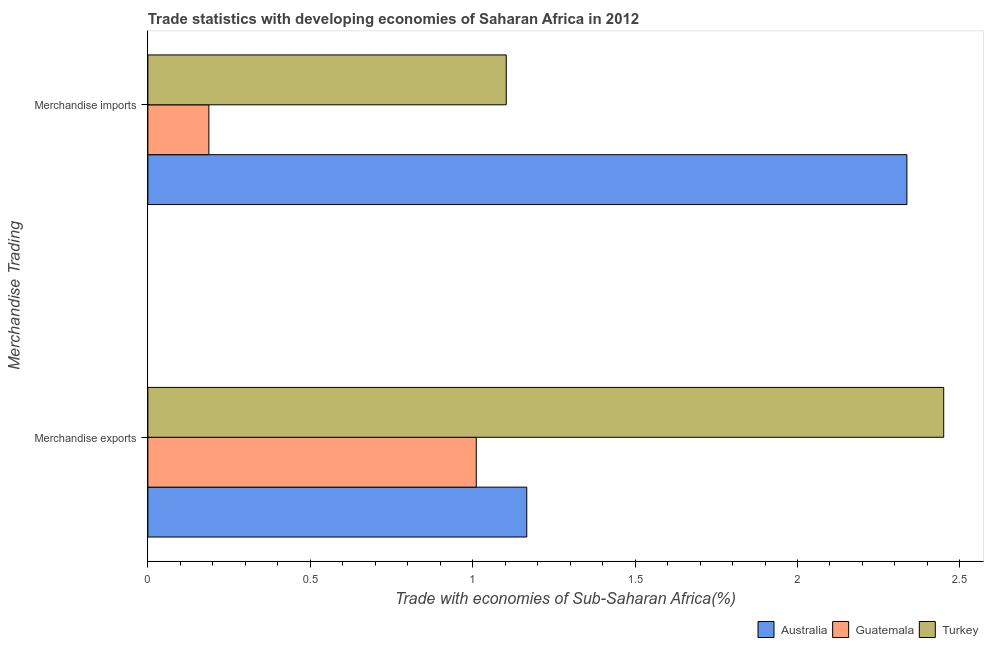How many different coloured bars are there?
Keep it short and to the point. 3. How many groups of bars are there?
Your answer should be very brief. 2. Are the number of bars per tick equal to the number of legend labels?
Offer a very short reply. Yes. How many bars are there on the 1st tick from the bottom?
Keep it short and to the point. 3. What is the label of the 1st group of bars from the top?
Offer a terse response. Merchandise imports. What is the merchandise exports in Australia?
Offer a very short reply. 1.17. Across all countries, what is the maximum merchandise exports?
Offer a very short reply. 2.45. Across all countries, what is the minimum merchandise exports?
Give a very brief answer. 1.01. In which country was the merchandise imports minimum?
Your answer should be very brief. Guatemala. What is the total merchandise exports in the graph?
Keep it short and to the point. 4.63. What is the difference between the merchandise imports in Turkey and that in Australia?
Offer a terse response. -1.23. What is the difference between the merchandise imports in Australia and the merchandise exports in Guatemala?
Provide a succinct answer. 1.33. What is the average merchandise imports per country?
Keep it short and to the point. 1.21. What is the difference between the merchandise exports and merchandise imports in Turkey?
Your response must be concise. 1.35. What is the ratio of the merchandise imports in Turkey to that in Australia?
Your response must be concise. 0.47. Is the merchandise exports in Turkey less than that in Australia?
Give a very brief answer. No. In how many countries, is the merchandise imports greater than the average merchandise imports taken over all countries?
Your response must be concise. 1. What does the 1st bar from the top in Merchandise exports represents?
Offer a very short reply. Turkey. How many bars are there?
Provide a short and direct response. 6. How many countries are there in the graph?
Keep it short and to the point. 3. Are the values on the major ticks of X-axis written in scientific E-notation?
Make the answer very short. No. Does the graph contain any zero values?
Make the answer very short. No. Does the graph contain grids?
Provide a succinct answer. No. How are the legend labels stacked?
Offer a terse response. Horizontal. What is the title of the graph?
Provide a short and direct response. Trade statistics with developing economies of Saharan Africa in 2012. Does "Antigua and Barbuda" appear as one of the legend labels in the graph?
Ensure brevity in your answer.  No. What is the label or title of the X-axis?
Keep it short and to the point. Trade with economies of Sub-Saharan Africa(%). What is the label or title of the Y-axis?
Offer a very short reply. Merchandise Trading. What is the Trade with economies of Sub-Saharan Africa(%) of Australia in Merchandise exports?
Provide a succinct answer. 1.17. What is the Trade with economies of Sub-Saharan Africa(%) of Guatemala in Merchandise exports?
Provide a short and direct response. 1.01. What is the Trade with economies of Sub-Saharan Africa(%) of Turkey in Merchandise exports?
Make the answer very short. 2.45. What is the Trade with economies of Sub-Saharan Africa(%) in Australia in Merchandise imports?
Keep it short and to the point. 2.34. What is the Trade with economies of Sub-Saharan Africa(%) in Guatemala in Merchandise imports?
Provide a succinct answer. 0.19. What is the Trade with economies of Sub-Saharan Africa(%) in Turkey in Merchandise imports?
Your answer should be compact. 1.1. Across all Merchandise Trading, what is the maximum Trade with economies of Sub-Saharan Africa(%) of Australia?
Give a very brief answer. 2.34. Across all Merchandise Trading, what is the maximum Trade with economies of Sub-Saharan Africa(%) of Guatemala?
Provide a succinct answer. 1.01. Across all Merchandise Trading, what is the maximum Trade with economies of Sub-Saharan Africa(%) of Turkey?
Your response must be concise. 2.45. Across all Merchandise Trading, what is the minimum Trade with economies of Sub-Saharan Africa(%) of Australia?
Ensure brevity in your answer.  1.17. Across all Merchandise Trading, what is the minimum Trade with economies of Sub-Saharan Africa(%) in Guatemala?
Give a very brief answer. 0.19. Across all Merchandise Trading, what is the minimum Trade with economies of Sub-Saharan Africa(%) of Turkey?
Provide a succinct answer. 1.1. What is the total Trade with economies of Sub-Saharan Africa(%) of Australia in the graph?
Make the answer very short. 3.5. What is the total Trade with economies of Sub-Saharan Africa(%) in Guatemala in the graph?
Ensure brevity in your answer.  1.2. What is the total Trade with economies of Sub-Saharan Africa(%) in Turkey in the graph?
Your answer should be compact. 3.55. What is the difference between the Trade with economies of Sub-Saharan Africa(%) in Australia in Merchandise exports and that in Merchandise imports?
Keep it short and to the point. -1.17. What is the difference between the Trade with economies of Sub-Saharan Africa(%) in Guatemala in Merchandise exports and that in Merchandise imports?
Keep it short and to the point. 0.82. What is the difference between the Trade with economies of Sub-Saharan Africa(%) in Turkey in Merchandise exports and that in Merchandise imports?
Your answer should be compact. 1.35. What is the difference between the Trade with economies of Sub-Saharan Africa(%) in Australia in Merchandise exports and the Trade with economies of Sub-Saharan Africa(%) in Guatemala in Merchandise imports?
Your answer should be very brief. 0.98. What is the difference between the Trade with economies of Sub-Saharan Africa(%) of Australia in Merchandise exports and the Trade with economies of Sub-Saharan Africa(%) of Turkey in Merchandise imports?
Ensure brevity in your answer.  0.06. What is the difference between the Trade with economies of Sub-Saharan Africa(%) in Guatemala in Merchandise exports and the Trade with economies of Sub-Saharan Africa(%) in Turkey in Merchandise imports?
Your answer should be very brief. -0.09. What is the average Trade with economies of Sub-Saharan Africa(%) in Australia per Merchandise Trading?
Make the answer very short. 1.75. What is the average Trade with economies of Sub-Saharan Africa(%) of Guatemala per Merchandise Trading?
Provide a succinct answer. 0.6. What is the average Trade with economies of Sub-Saharan Africa(%) of Turkey per Merchandise Trading?
Provide a succinct answer. 1.78. What is the difference between the Trade with economies of Sub-Saharan Africa(%) of Australia and Trade with economies of Sub-Saharan Africa(%) of Guatemala in Merchandise exports?
Keep it short and to the point. 0.16. What is the difference between the Trade with economies of Sub-Saharan Africa(%) in Australia and Trade with economies of Sub-Saharan Africa(%) in Turkey in Merchandise exports?
Make the answer very short. -1.28. What is the difference between the Trade with economies of Sub-Saharan Africa(%) in Guatemala and Trade with economies of Sub-Saharan Africa(%) in Turkey in Merchandise exports?
Make the answer very short. -1.44. What is the difference between the Trade with economies of Sub-Saharan Africa(%) in Australia and Trade with economies of Sub-Saharan Africa(%) in Guatemala in Merchandise imports?
Offer a very short reply. 2.15. What is the difference between the Trade with economies of Sub-Saharan Africa(%) in Australia and Trade with economies of Sub-Saharan Africa(%) in Turkey in Merchandise imports?
Ensure brevity in your answer.  1.23. What is the difference between the Trade with economies of Sub-Saharan Africa(%) in Guatemala and Trade with economies of Sub-Saharan Africa(%) in Turkey in Merchandise imports?
Ensure brevity in your answer.  -0.92. What is the ratio of the Trade with economies of Sub-Saharan Africa(%) of Australia in Merchandise exports to that in Merchandise imports?
Your answer should be very brief. 0.5. What is the ratio of the Trade with economies of Sub-Saharan Africa(%) in Guatemala in Merchandise exports to that in Merchandise imports?
Give a very brief answer. 5.38. What is the ratio of the Trade with economies of Sub-Saharan Africa(%) of Turkey in Merchandise exports to that in Merchandise imports?
Give a very brief answer. 2.22. What is the difference between the highest and the second highest Trade with economies of Sub-Saharan Africa(%) of Australia?
Provide a succinct answer. 1.17. What is the difference between the highest and the second highest Trade with economies of Sub-Saharan Africa(%) in Guatemala?
Offer a terse response. 0.82. What is the difference between the highest and the second highest Trade with economies of Sub-Saharan Africa(%) of Turkey?
Give a very brief answer. 1.35. What is the difference between the highest and the lowest Trade with economies of Sub-Saharan Africa(%) of Australia?
Your answer should be very brief. 1.17. What is the difference between the highest and the lowest Trade with economies of Sub-Saharan Africa(%) in Guatemala?
Ensure brevity in your answer.  0.82. What is the difference between the highest and the lowest Trade with economies of Sub-Saharan Africa(%) in Turkey?
Ensure brevity in your answer.  1.35. 